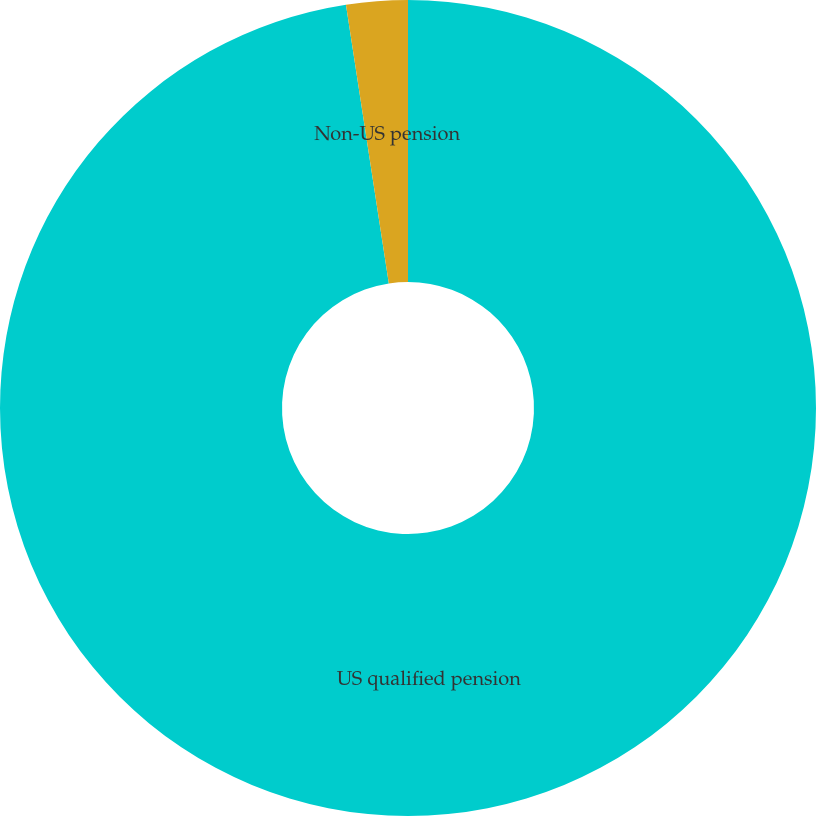Convert chart to OTSL. <chart><loc_0><loc_0><loc_500><loc_500><pie_chart><fcel>US qualified pension<fcel>Non-US pension<nl><fcel>97.57%<fcel>2.43%<nl></chart> 